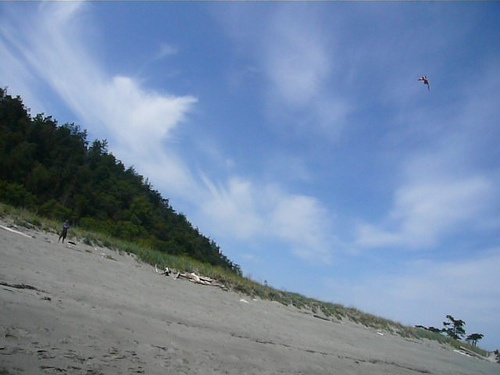Describe the objects in this image and their specific colors. I can see people in gray and black tones and kite in gray and navy tones in this image. 